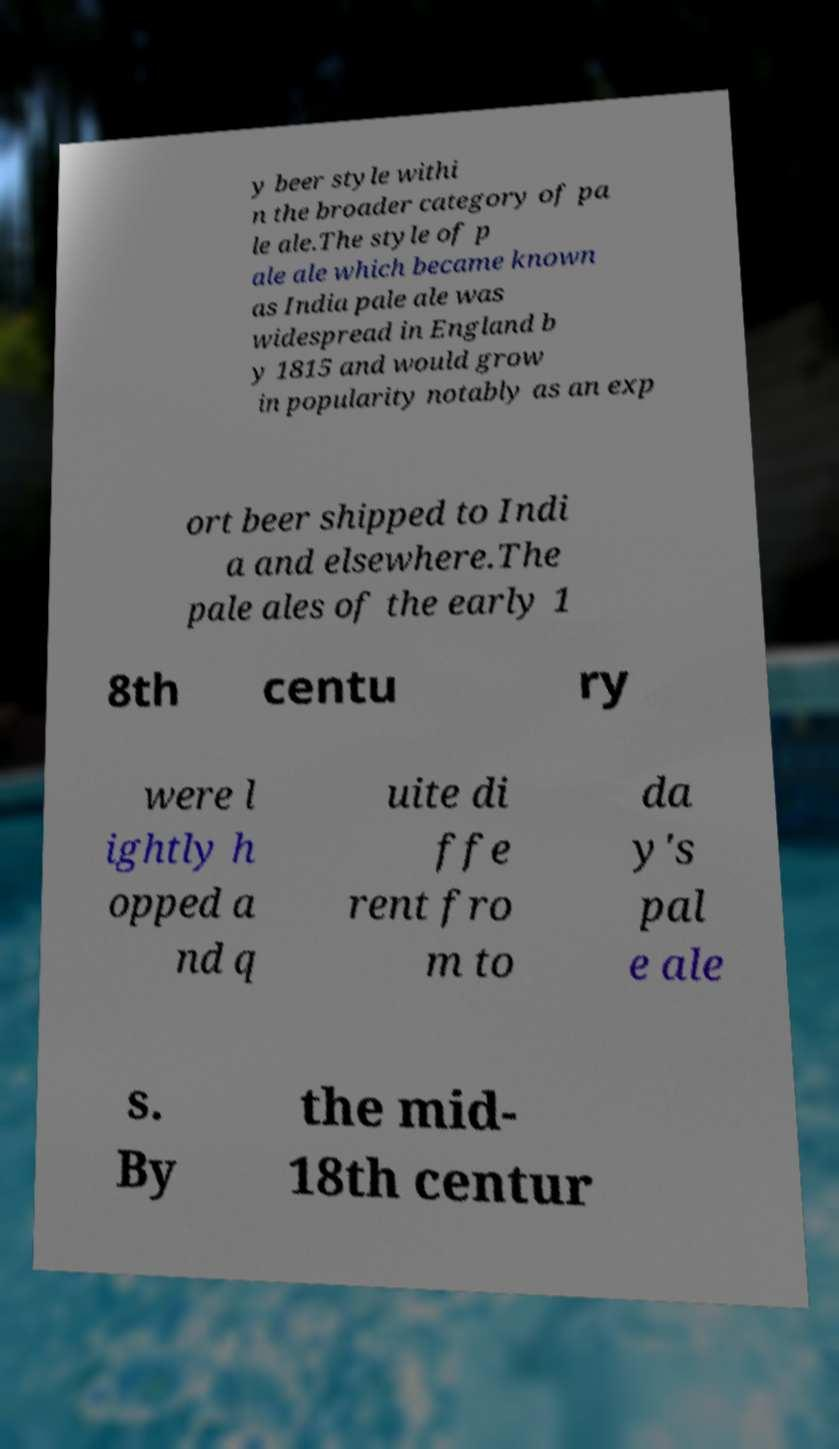What messages or text are displayed in this image? I need them in a readable, typed format. y beer style withi n the broader category of pa le ale.The style of p ale ale which became known as India pale ale was widespread in England b y 1815 and would grow in popularity notably as an exp ort beer shipped to Indi a and elsewhere.The pale ales of the early 1 8th centu ry were l ightly h opped a nd q uite di ffe rent fro m to da y's pal e ale s. By the mid- 18th centur 